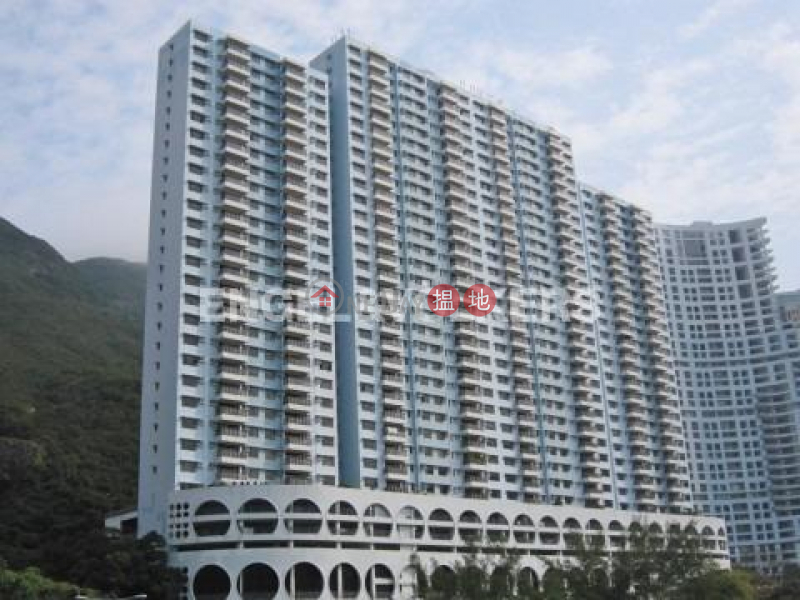What role might the surrounding hills play in the local weather conditions observed in this area? The surrounding hills could significantly influence local weather patterns, potentially acting as barriers that trap moisture and contribute to higher rainfall in the area. This can lead to lush vegetation, as seen in the image. Moreover, these hills can also provide a shield against stronger winds, creating a more stabilized and milder local climate, which supports the growth of greenery and possibly affects the temperature by keeping the area cooler during hot days. 